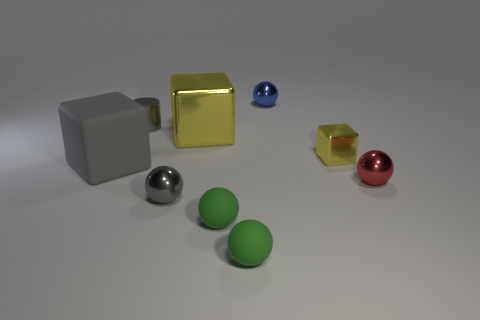What number of tiny objects are either yellow metal objects or red metallic objects?
Provide a short and direct response. 2. There is a blue thing; are there any shiny balls on the right side of it?
Ensure brevity in your answer.  Yes. Are there the same number of large rubber things behind the big rubber thing and tiny yellow metallic balls?
Your response must be concise. Yes. What size is the blue metal object that is the same shape as the red metal object?
Ensure brevity in your answer.  Small. Do the small red thing and the large object that is to the left of the tiny metal cylinder have the same shape?
Your answer should be compact. No. There is a block in front of the block that is to the right of the blue thing; how big is it?
Your answer should be compact. Large. Are there an equal number of big yellow objects right of the tiny blue metallic sphere and gray objects behind the tiny red ball?
Your answer should be compact. No. What is the color of the large metallic object that is the same shape as the small yellow thing?
Offer a very short reply. Yellow. What number of small things have the same color as the rubber block?
Ensure brevity in your answer.  2. Do the tiny gray shiny thing behind the tiny red thing and the blue metal object have the same shape?
Give a very brief answer. No. 